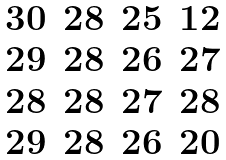Convert formula to latex. <formula><loc_0><loc_0><loc_500><loc_500>\begin{matrix} 3 0 & 2 8 & 2 5 & 1 2 \\ 2 9 & 2 8 & 2 6 & 2 7 \\ 2 8 & 2 8 & 2 7 & 2 8 \\ 2 9 & 2 8 & 2 6 & 2 0 \end{matrix}</formula> 